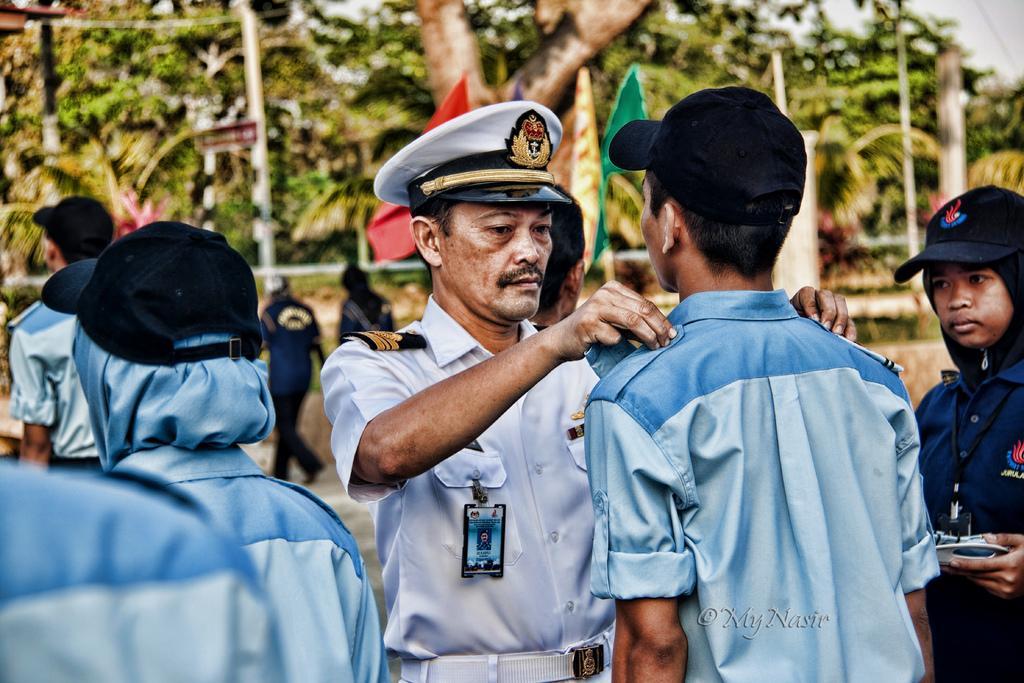Describe this image in one or two sentences. In this image there is an officer in the middle who is keeping badge on the shoulder of the boy who is in front of him. In the background there are trees and flags. On the left side there are few other officers who are standing on the ground by wearing the blue cap. 